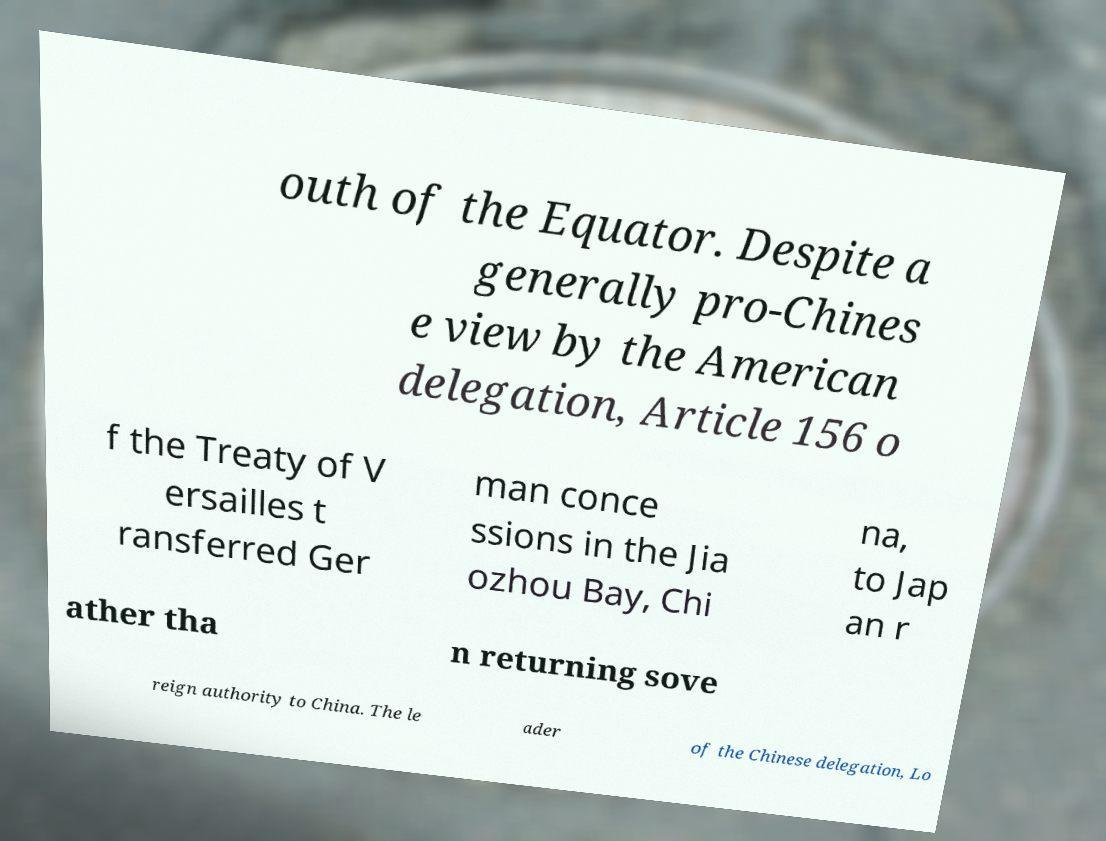Could you extract and type out the text from this image? outh of the Equator. Despite a generally pro-Chines e view by the American delegation, Article 156 o f the Treaty of V ersailles t ransferred Ger man conce ssions in the Jia ozhou Bay, Chi na, to Jap an r ather tha n returning sove reign authority to China. The le ader of the Chinese delegation, Lo 